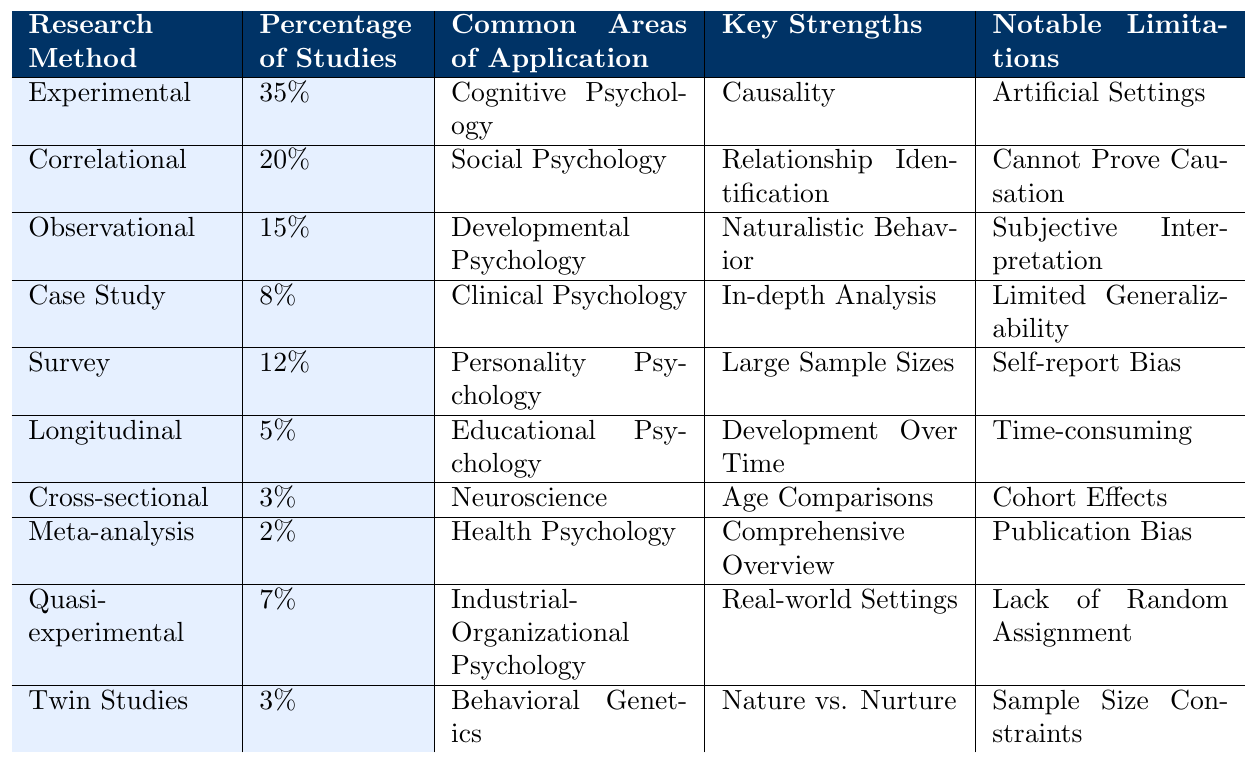What research method has the highest percentage of studies? The table shows the "Percentage of Studies" for each research method. By looking at the values, "Experimental" has the highest percentage at 35%.
Answer: Experimental Which research method is most commonly used in Clinical Psychology? Looking at the "Common Areas of Application," "Case Study" is the method listed under Clinical Psychology.
Answer: Case Study How many research methods have a percentage of studies less than 5%? The table lists the percentages for each research method. Only "Longitudinal" and "Meta-analysis" have percentages of 5% and 2%, respectively, meaning there are no methods with less than 5%.
Answer: 0 What is the difference in percentage of studies between Experimental and Survey methods? The percentage of studies for "Experimental" is 35%, and for "Survey" it is 12%. The difference is 35% - 12% = 23%.
Answer: 23% Are there any research methods that have the same percentage of studies? The table shows unique percentages for all research methods listed. None of the methods share the same percentage.
Answer: No What is the average percentage of studies for qualitative research methods? Considering methods that focus more on qualitative aspects, we identify "Case Study," "Observational," and "Survey" with percentages of 8%, 15%, and 12%, respectively. We calculate the average: (8 + 15 + 12) / 3 = 35 / 3 ≈ 11.67%.
Answer: 11.67% Which research method is known for its in-depth analysis, and what is its notable limitation? From the table, "Case Study" is known for "In-depth Analysis," while its notable limitation is "Limited Generalizability."
Answer: In-depth Analysis; Limited Generalizability How many research methods are primarily used in Developmental Psychology and Educational Psychology combined? The table indicates "Observational" for Developmental Psychology and "Longitudinal" for Educational Psychology. Thus, we have a total of 2 unique methods used for these fields.
Answer: 2 True or False: The percentage of studies for Twin Studies is greater than that for Longitudinal Studies. The percentage for Twin Studies is 3%, and for Longitudinal, it is 5%. Therefore, Twin Studies does not have a greater percentage.
Answer: False What is the notable limitation of the method with the lowest percentage of studies? "Meta-analysis" has the lowest percentage at 2%, and its notable limitation is "Publication Bias."
Answer: Publication Bias 